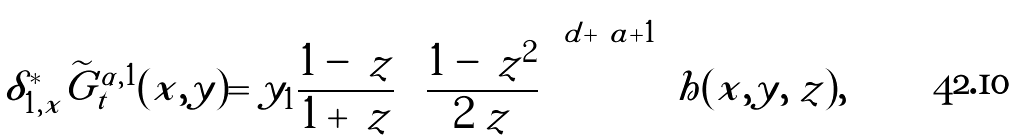<formula> <loc_0><loc_0><loc_500><loc_500>\delta _ { 1 , x } ^ { * } \widetilde { G } _ { t } ^ { \alpha , 1 } ( x , y ) = y _ { 1 } \frac { 1 - \ z } { 1 + \ z } \left ( \frac { 1 - \ z ^ { 2 } } { 2 \ z } \right ) ^ { d + | \ a | + 1 } h ( x , y , \ z ) ,</formula> 